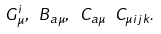<formula> <loc_0><loc_0><loc_500><loc_500>G _ { \mu } ^ { i } , \ B _ { a \mu } , \ C _ { a \mu } \ C _ { \mu i j k } .</formula> 